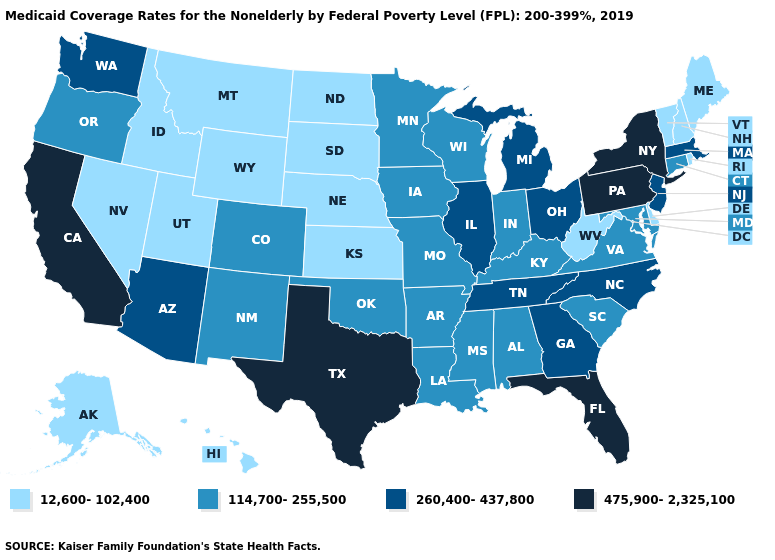What is the value of Minnesota?
Keep it brief. 114,700-255,500. Is the legend a continuous bar?
Answer briefly. No. What is the highest value in states that border Massachusetts?
Short answer required. 475,900-2,325,100. Name the states that have a value in the range 475,900-2,325,100?
Quick response, please. California, Florida, New York, Pennsylvania, Texas. Name the states that have a value in the range 12,600-102,400?
Concise answer only. Alaska, Delaware, Hawaii, Idaho, Kansas, Maine, Montana, Nebraska, Nevada, New Hampshire, North Dakota, Rhode Island, South Dakota, Utah, Vermont, West Virginia, Wyoming. Name the states that have a value in the range 12,600-102,400?
Give a very brief answer. Alaska, Delaware, Hawaii, Idaho, Kansas, Maine, Montana, Nebraska, Nevada, New Hampshire, North Dakota, Rhode Island, South Dakota, Utah, Vermont, West Virginia, Wyoming. What is the value of Connecticut?
Short answer required. 114,700-255,500. Does Maine have the lowest value in the USA?
Give a very brief answer. Yes. Does Idaho have the highest value in the West?
Give a very brief answer. No. Among the states that border Colorado , does Nebraska have the lowest value?
Give a very brief answer. Yes. Does the map have missing data?
Concise answer only. No. What is the value of Maine?
Be succinct. 12,600-102,400. Does West Virginia have the lowest value in the USA?
Be succinct. Yes. Does the map have missing data?
Give a very brief answer. No. Name the states that have a value in the range 114,700-255,500?
Quick response, please. Alabama, Arkansas, Colorado, Connecticut, Indiana, Iowa, Kentucky, Louisiana, Maryland, Minnesota, Mississippi, Missouri, New Mexico, Oklahoma, Oregon, South Carolina, Virginia, Wisconsin. 